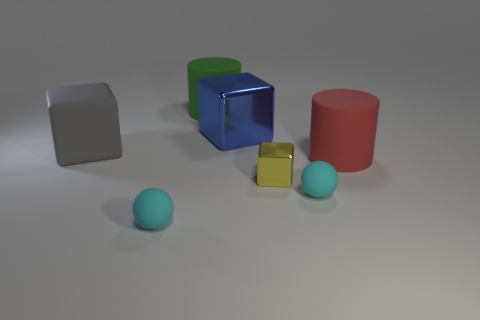What is the shape of the tiny rubber object that is in front of the small cyan object on the right side of the small cyan object to the left of the large green cylinder?
Keep it short and to the point. Sphere. There is a red thing that is the same size as the green rubber thing; what shape is it?
Keep it short and to the point. Cylinder. What number of big matte blocks are in front of the large rubber object that is in front of the large block that is to the left of the big blue metal object?
Your answer should be compact. 0. Are there more small shiny things behind the large gray cube than yellow shiny cubes left of the blue metal cube?
Your answer should be very brief. No. What number of big matte things are the same shape as the blue metallic object?
Give a very brief answer. 1. What number of things are either shiny cubes in front of the gray block or shiny blocks in front of the gray matte object?
Provide a succinct answer. 1. What is the material of the sphere to the left of the cyan matte ball on the right side of the small sphere on the left side of the blue shiny thing?
Provide a short and direct response. Rubber. There is a matte cylinder to the left of the blue metallic block; does it have the same color as the large metal object?
Your answer should be very brief. No. There is a thing that is both on the left side of the large green thing and in front of the gray rubber thing; what material is it made of?
Your response must be concise. Rubber. Are there any yellow metallic cylinders that have the same size as the gray object?
Offer a terse response. No. 